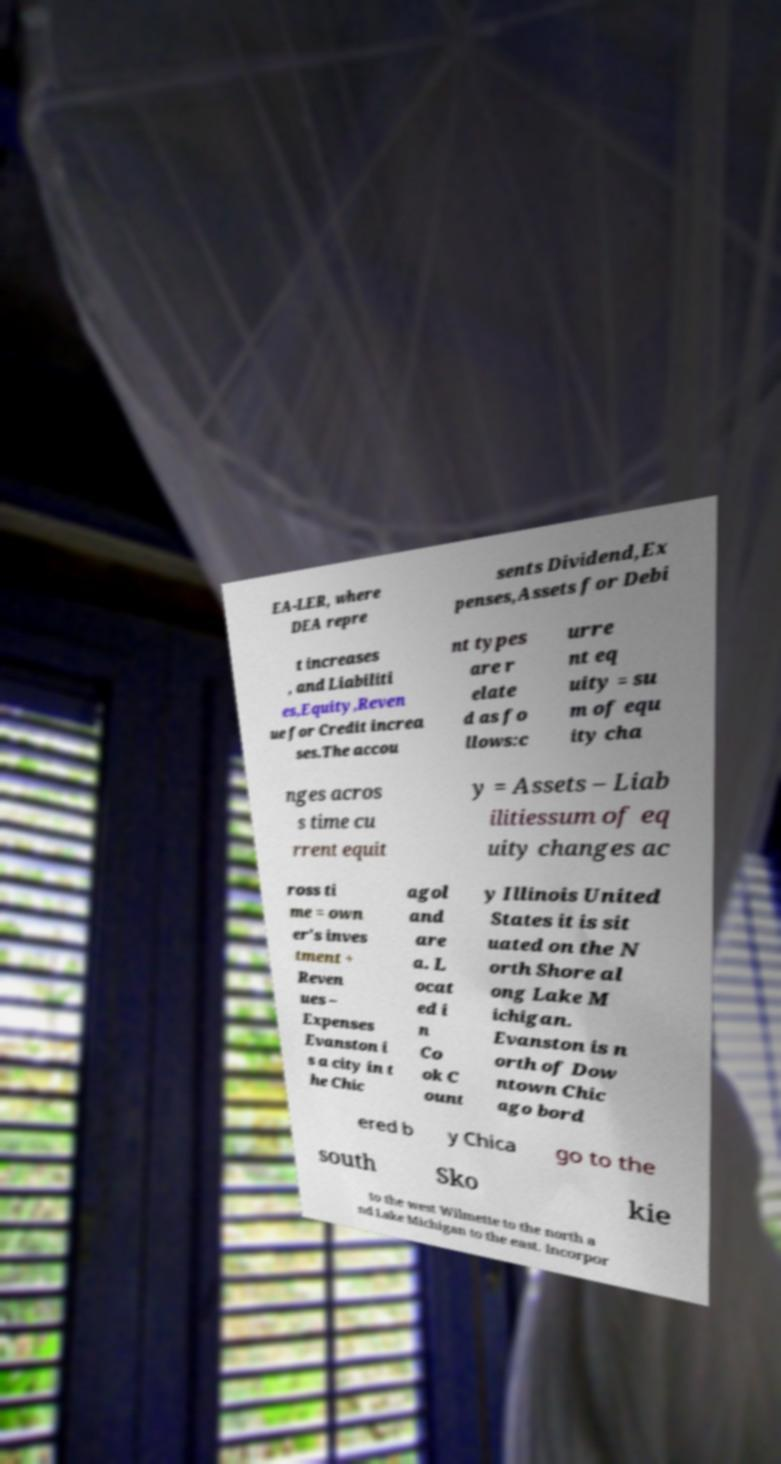There's text embedded in this image that I need extracted. Can you transcribe it verbatim? EA-LER, where DEA repre sents Dividend,Ex penses,Assets for Debi t increases , and Liabiliti es,Equity,Reven ue for Credit increa ses.The accou nt types are r elate d as fo llows:c urre nt eq uity = su m of equ ity cha nges acros s time cu rrent equit y = Assets – Liab ilitiessum of eq uity changes ac ross ti me = own er's inves tment + Reven ues – Expenses Evanston i s a city in t he Chic agol and are a. L ocat ed i n Co ok C ount y Illinois United States it is sit uated on the N orth Shore al ong Lake M ichigan. Evanston is n orth of Dow ntown Chic ago bord ered b y Chica go to the south Sko kie to the west Wilmette to the north a nd Lake Michigan to the east. Incorpor 